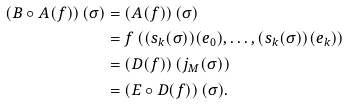Convert formula to latex. <formula><loc_0><loc_0><loc_500><loc_500>\left ( B \circ A ( f ) \right ) ( \sigma ) & = \left ( A ( f ) \right ) ( \sigma ) \\ & = f \left ( ( s _ { k } ( \sigma ) ) ( e _ { 0 } ) , \dots , ( s _ { k } ( \sigma ) ) ( e _ { k } ) \right ) \\ & = \left ( D ( f ) \right ) \left ( j _ { M } ( \sigma ) \right ) \\ & = \left ( E \circ D ( f ) \right ) ( \sigma ) .</formula> 